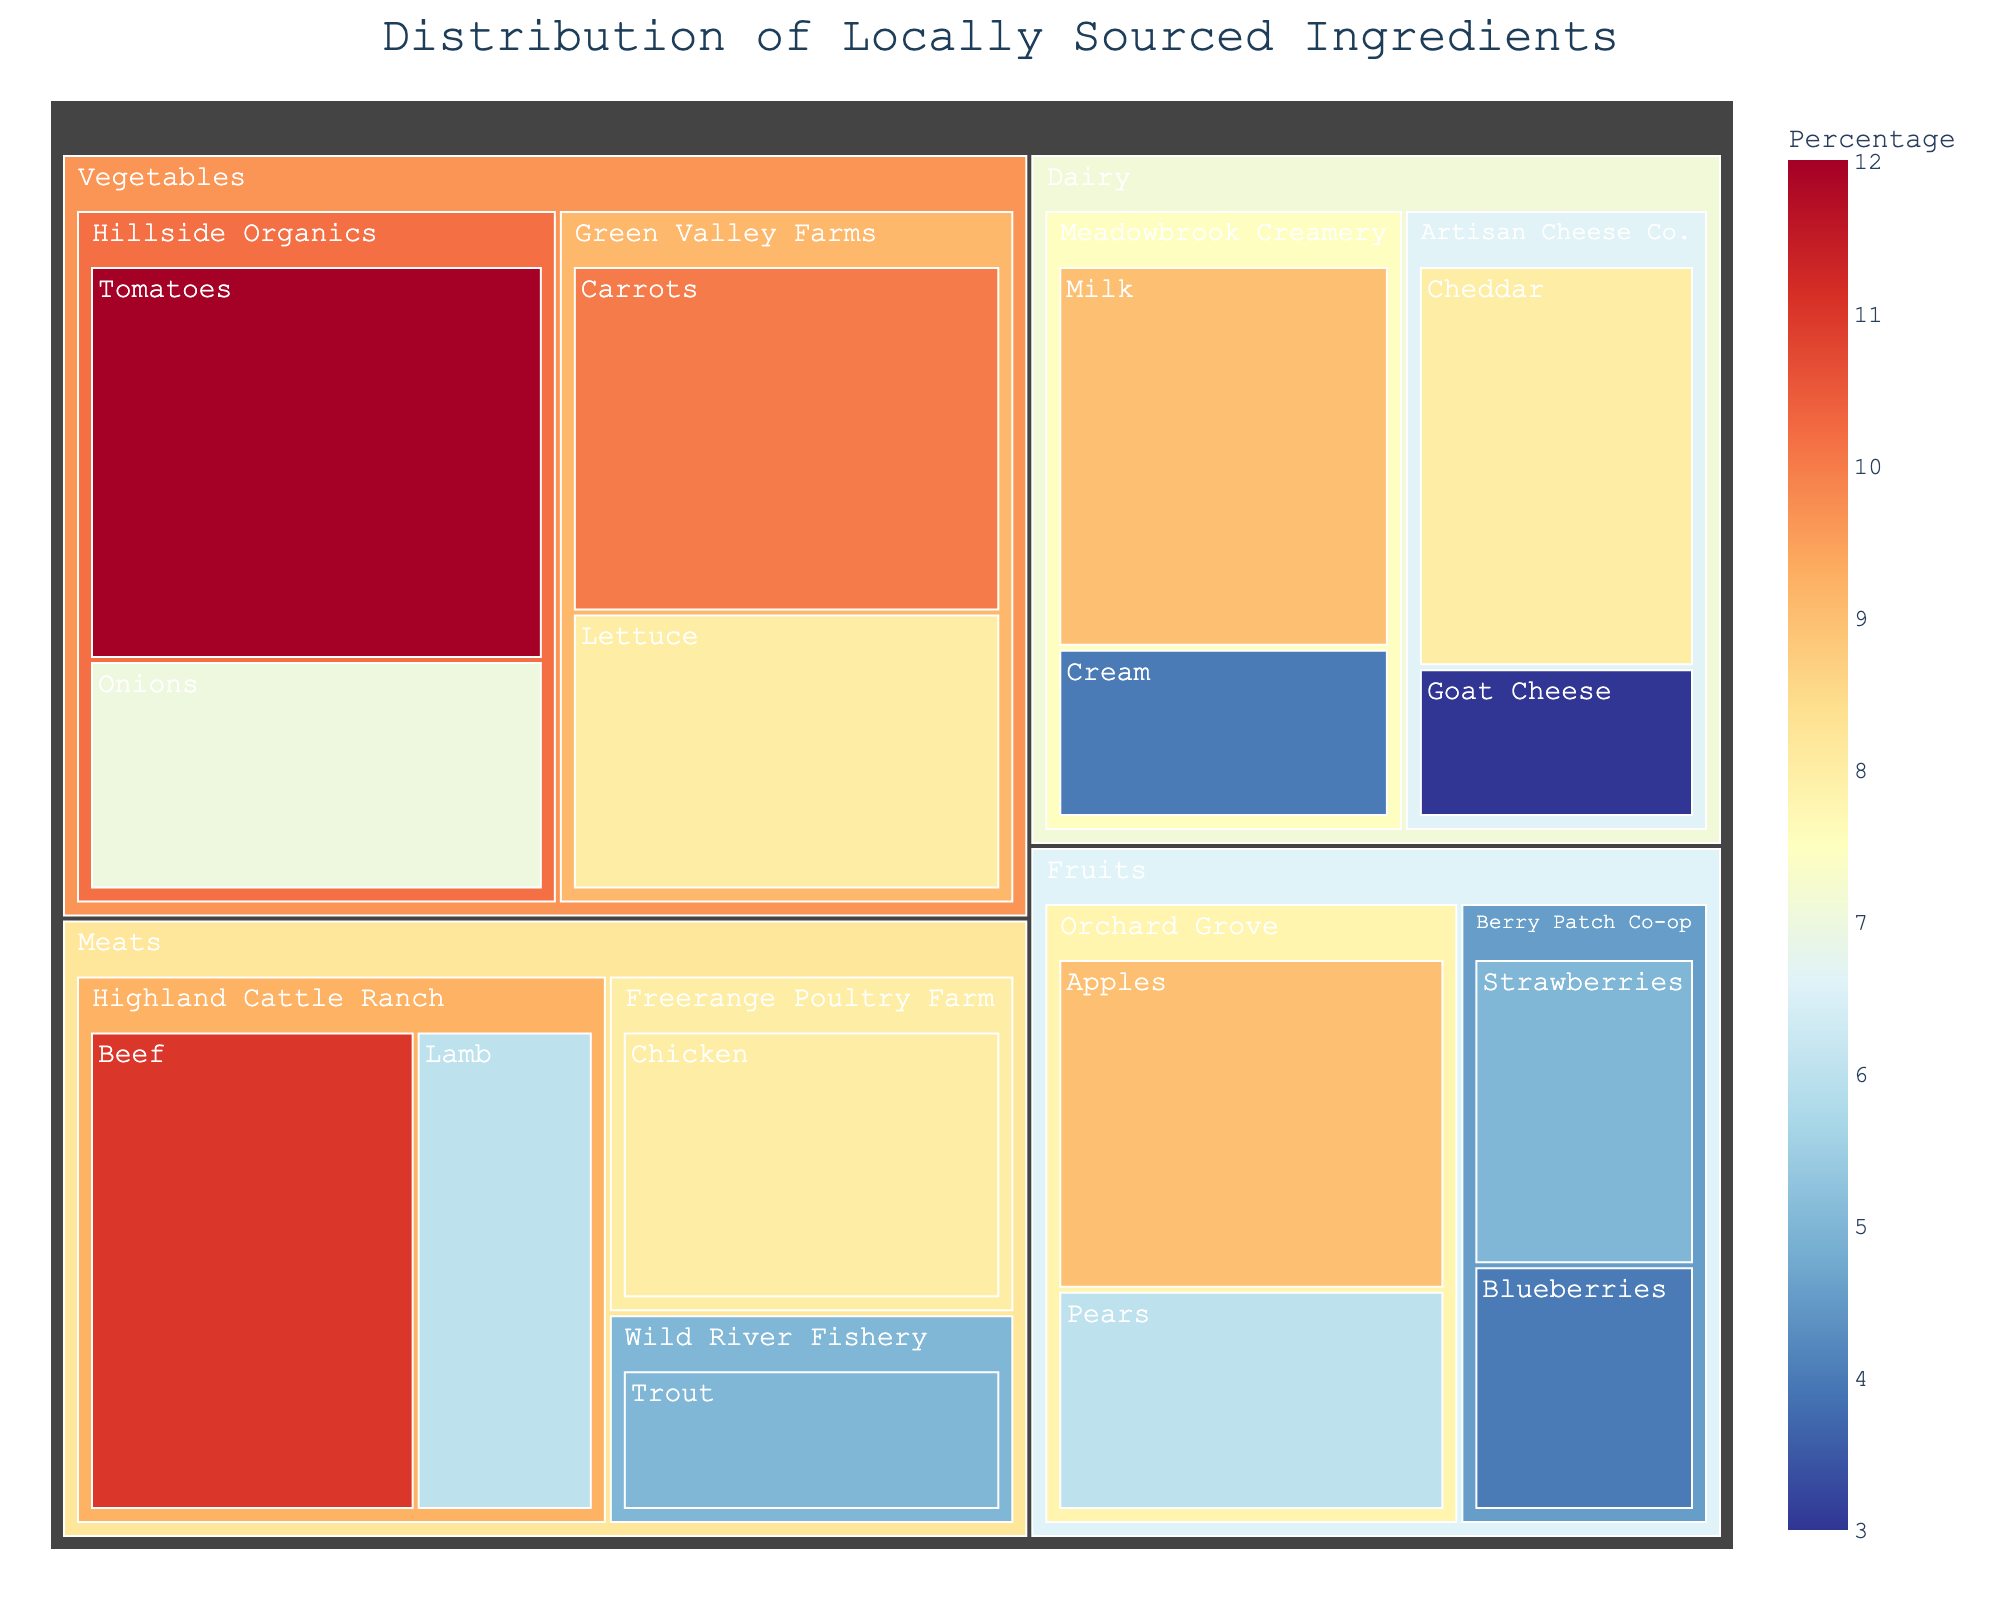What's the title of the plot? The title is prominently displayed at the top center of the figure, which is a basic element of the plot.
Answer: Distribution of Locally Sourced Ingredients Which category has the highest total percentage of ingredients? To determine this, sum up the percentages of each item in each category. Vegetables: 10+8+12+7=37, Fruits: 9+6+5+4=24, Meats: 11+6+8+5=30, Dairy: 9+4+8+3=24. The category with the highest total percentage is Vegetables.
Answer: Vegetables How many suppliers are there in the Dairy category? The treemap breaks down each category into suppliers. Count the distinct suppliers in the Dairy category.
Answer: 2 Which supplier provides the highest variety of items? Check each supplier and count how many distinct items they provide. Green Valley Farms: 2, Hillside Organics: 2, Orchard Grove: 2, Berry Patch Co-op: 2, Highland Cattle Ranch: 2, Freerange Poultry Farm: 1, Wild River Fishery: 1, Meadowbrook Creamery: 2, Artisan Cheese Co.: 2. Multiple suppliers provide the highest variety, which is 2 items each.
Answer: Multiple suppliers (2 items each) What is the percentage of ingredients supplied by Orchard Grove? Sum the percentages of all items provided by Orchard Grove. Apples: 9, Pears: 6. Total = 9+6=15
Answer: 15% Which ingredient has the lowest percentage in the Dairy category? Look within the Dairy category and identify the item with the smallest percentage. Milk: 9, Cream: 4, Cheddar: 8, Goat Cheese: 3. The ingredient with the lowest percentage is Goat Cheese.
Answer: Goat Cheese Compare the total percentages of items from Highland Cattle Ranch and Freerange Poultry Farm. Which one is higher? Sum the percentages for each supplier: Highland Cattle Ranch: Beef: 11, Lamb: 6. Total = 17. Freerange Poultry Farm: Chicken: 8. Total = 8. Highland Cattle Ranch has the higher total.
Answer: Highland Cattle Ranch What percentage of the total locally sourced ingredients is Chicken? Refer to the value represented by Chicken in the figure, as a single step calculation.
Answer: 8% How does the percentage of locally sourced Blueberries compare to that of Strawberries? Check the individual percentages for Blueberries and Strawberries and compare. Blueberries: 4, Strawberries: 5. Strawberries have a higher percentage than Blueberries.
Answer: Strawberries are higher 